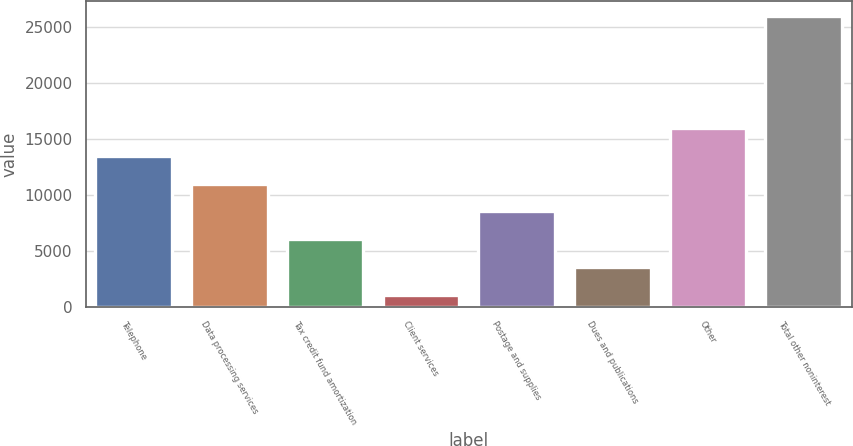Convert chart to OTSL. <chart><loc_0><loc_0><loc_500><loc_500><bar_chart><fcel>Telephone<fcel>Data processing services<fcel>Tax credit fund amortization<fcel>Client services<fcel>Postage and supplies<fcel>Dues and publications<fcel>Other<fcel>Total other noninterest<nl><fcel>13514.5<fcel>11016<fcel>6019<fcel>1022<fcel>8517.5<fcel>3520.5<fcel>16013<fcel>26007<nl></chart> 